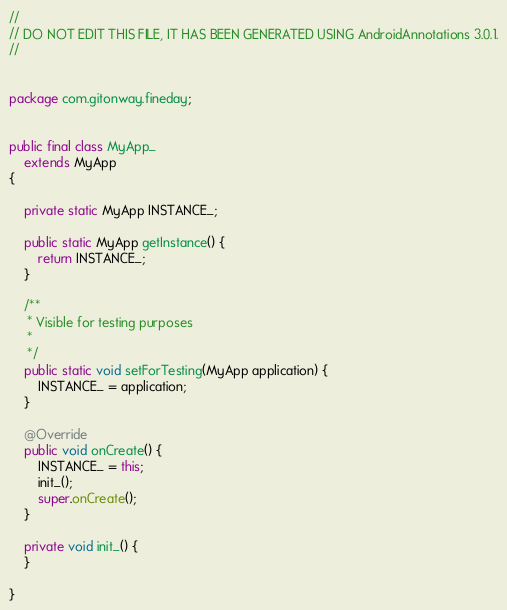Convert code to text. <code><loc_0><loc_0><loc_500><loc_500><_Java_>//
// DO NOT EDIT THIS FILE, IT HAS BEEN GENERATED USING AndroidAnnotations 3.0.1.
//


package com.gitonway.fineday;


public final class MyApp_
    extends MyApp
{

    private static MyApp INSTANCE_;

    public static MyApp getInstance() {
        return INSTANCE_;
    }

    /**
     * Visible for testing purposes
     * 
     */
    public static void setForTesting(MyApp application) {
        INSTANCE_ = application;
    }

    @Override
    public void onCreate() {
        INSTANCE_ = this;
        init_();
        super.onCreate();
    }

    private void init_() {
    }

}
</code> 